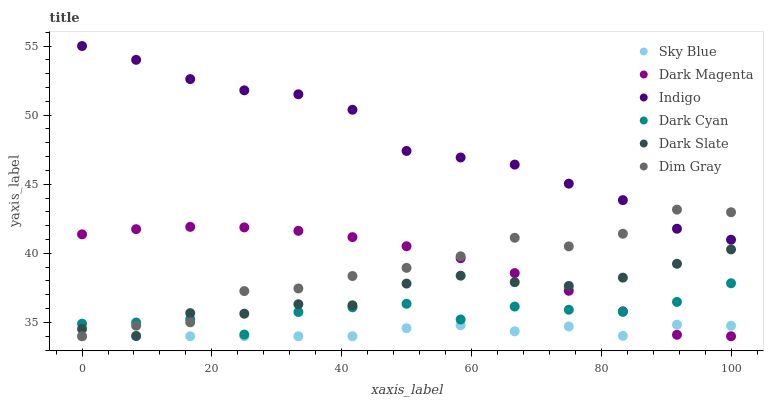Does Sky Blue have the minimum area under the curve?
Answer yes or no. Yes. Does Indigo have the maximum area under the curve?
Answer yes or no. Yes. Does Dark Magenta have the minimum area under the curve?
Answer yes or no. No. Does Dark Magenta have the maximum area under the curve?
Answer yes or no. No. Is Dark Magenta the smoothest?
Answer yes or no. Yes. Is Dim Gray the roughest?
Answer yes or no. Yes. Is Indigo the smoothest?
Answer yes or no. No. Is Indigo the roughest?
Answer yes or no. No. Does Dim Gray have the lowest value?
Answer yes or no. Yes. Does Indigo have the lowest value?
Answer yes or no. No. Does Indigo have the highest value?
Answer yes or no. Yes. Does Dark Magenta have the highest value?
Answer yes or no. No. Is Sky Blue less than Indigo?
Answer yes or no. Yes. Is Indigo greater than Dark Slate?
Answer yes or no. Yes. Does Dark Magenta intersect Dark Cyan?
Answer yes or no. Yes. Is Dark Magenta less than Dark Cyan?
Answer yes or no. No. Is Dark Magenta greater than Dark Cyan?
Answer yes or no. No. Does Sky Blue intersect Indigo?
Answer yes or no. No. 